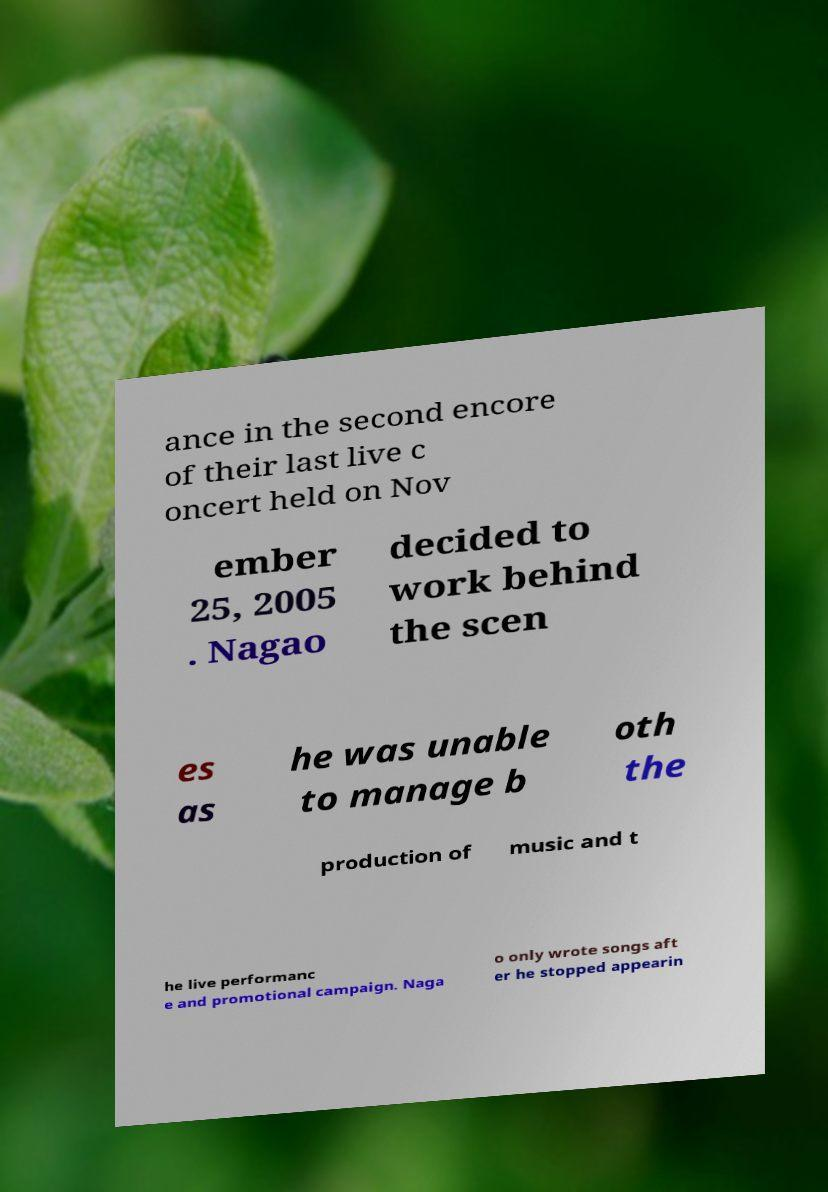Please identify and transcribe the text found in this image. ance in the second encore of their last live c oncert held on Nov ember 25, 2005 . Nagao decided to work behind the scen es as he was unable to manage b oth the production of music and t he live performanc e and promotional campaign. Naga o only wrote songs aft er he stopped appearin 